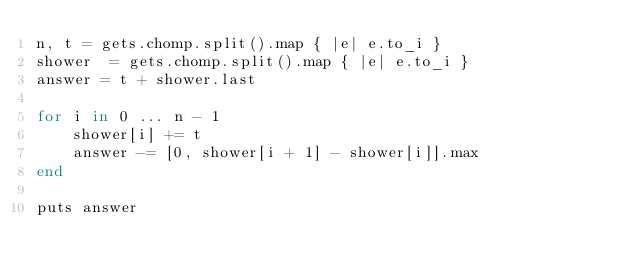Convert code to text. <code><loc_0><loc_0><loc_500><loc_500><_Ruby_>n, t = gets.chomp.split().map { |e| e.to_i }
shower  = gets.chomp.split().map { |e| e.to_i }
answer = t + shower.last

for i in 0 ... n - 1
    shower[i] += t
    answer -= [0, shower[i + 1] - shower[i]].max
end

puts answer
</code> 